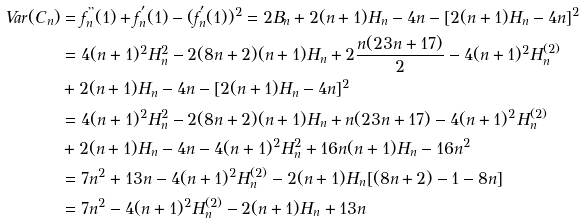Convert formula to latex. <formula><loc_0><loc_0><loc_500><loc_500>V a r ( C _ { n } ) & = f _ { n } ^ { " } ( 1 ) + f _ { n } ^ { ^ { \prime } } ( 1 ) - ( f _ { n } ^ { ^ { \prime } } ( 1 ) ) ^ { 2 } = 2 B _ { n } + 2 ( n + 1 ) H _ { n } - 4 n - [ 2 ( n + 1 ) H _ { n } - 4 n ] ^ { 2 } \\ & = 4 ( n + 1 ) ^ { 2 } H _ { n } ^ { 2 } - 2 ( 8 n + 2 ) ( n + 1 ) H _ { n } + 2 \frac { n ( 2 3 n + 1 7 ) } { 2 } - 4 ( n + 1 ) ^ { 2 } H _ { n } ^ { ( 2 ) } \\ & + 2 ( n + 1 ) H _ { n } - 4 n - [ 2 ( n + 1 ) H _ { n } - 4 n ] ^ { 2 } \\ & = 4 ( n + 1 ) ^ { 2 } H _ { n } ^ { 2 } - 2 ( 8 n + 2 ) ( n + 1 ) H _ { n } + n ( 2 3 n + 1 7 ) - 4 ( n + 1 ) ^ { 2 } H _ { n } ^ { ( 2 ) } \\ & + 2 ( n + 1 ) H _ { n } - 4 n - 4 ( n + 1 ) ^ { 2 } H ^ { 2 } _ { n } + 1 6 n ( n + 1 ) H _ { n } - 1 6 n ^ { 2 } \\ & = 7 n ^ { 2 } + 1 3 n - 4 ( n + 1 ) ^ { 2 } H _ { n } ^ { ( 2 ) } - 2 ( n + 1 ) H _ { n } [ ( 8 n + 2 ) - 1 - 8 n ] \\ & = 7 n ^ { 2 } - 4 ( n + 1 ) ^ { 2 } H _ { n } ^ { ( 2 ) } - 2 ( n + 1 ) H _ { n } + 1 3 n</formula> 